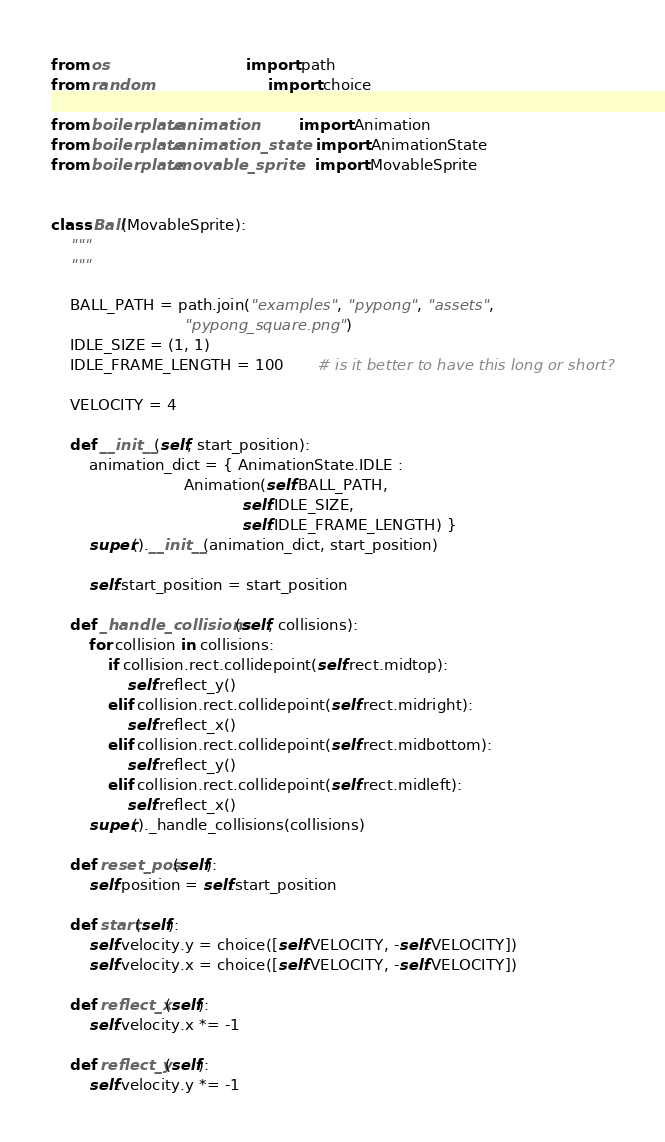Convert code to text. <code><loc_0><loc_0><loc_500><loc_500><_Python_>from os                             import path
from random                         import choice

from boilerplate.animation          import Animation
from boilerplate.animation_state    import AnimationState
from boilerplate.movable_sprite     import MovableSprite


class Ball(MovableSprite):
    """
    """

    BALL_PATH = path.join("examples", "pypong", "assets", 
                            "pypong_square.png")
    IDLE_SIZE = (1, 1)
    IDLE_FRAME_LENGTH = 100       # is it better to have this long or short?

    VELOCITY = 4

    def __init__(self, start_position):
        animation_dict = { AnimationState.IDLE : 
                            Animation(self.BALL_PATH,
                                        self.IDLE_SIZE,
                                        self.IDLE_FRAME_LENGTH) }
        super().__init__(animation_dict, start_position)

        self.start_position = start_position

    def _handle_collisions(self, collisions):
        for collision in collisions:
            if collision.rect.collidepoint(self.rect.midtop):
                self.reflect_y()
            elif collision.rect.collidepoint(self.rect.midright):
                self.reflect_x()
            elif collision.rect.collidepoint(self.rect.midbottom):
                self.reflect_y()
            elif collision.rect.collidepoint(self.rect.midleft):
                self.reflect_x()
        super()._handle_collisions(collisions)

    def reset_pos(self):
        self.position = self.start_position

    def start(self):
        self.velocity.y = choice([self.VELOCITY, -self.VELOCITY])
        self.velocity.x = choice([self.VELOCITY, -self.VELOCITY])

    def reflect_x(self):
        self.velocity.x *= -1

    def reflect_y(self):
        self.velocity.y *= -1
</code> 